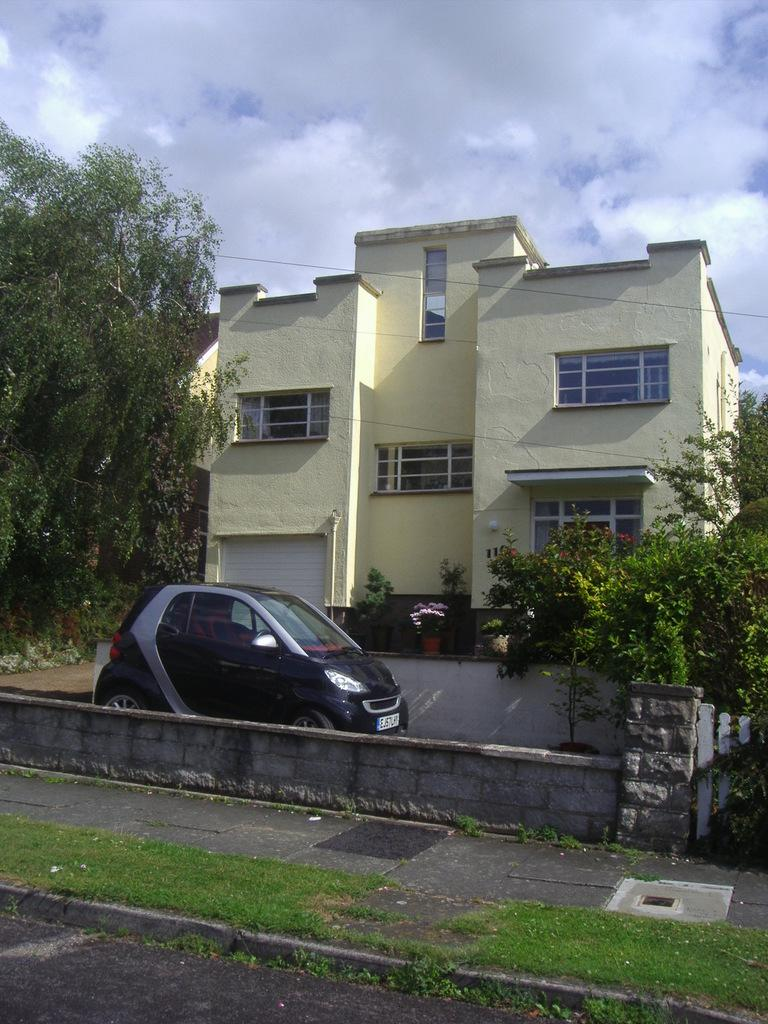What type of vegetation can be seen in the image? There is grass, trees, plants, and flowers in the image. What type of structures are present in the image? There are walls, a building, and a car in the image. What is visible in the background of the image? The sky is visible in the background of the image. Can you hear the flock of birds crying in the image? There are no birds or sounds present in the image, so it is not possible to hear any crying. 